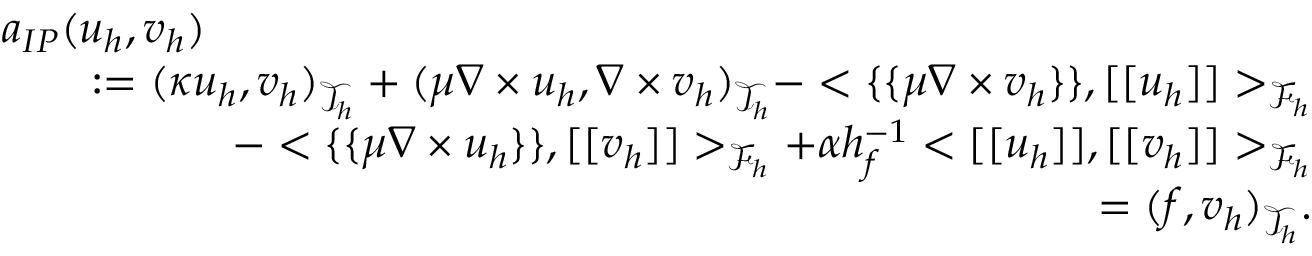Convert formula to latex. <formula><loc_0><loc_0><loc_500><loc_500>\begin{array} { r l r } { { a _ { I P } ( u _ { h } , v _ { h } ) } } \\ & { \colon = ( \kappa u _ { h } , v _ { h } ) _ { \mathcal { T } _ { h } } + ( \mu \nabla \times u _ { h } , \nabla \times v _ { h } ) _ { \mathcal { T } _ { h } } - < \{ \{ \mu \nabla \times v _ { h } \} \} , [ [ u _ { h } ] ] > _ { \mathcal { F } _ { h } } } \\ & { \quad - < \{ \{ \mu \nabla \times u _ { h } \} \} , [ [ v _ { h } ] ] > _ { \mathcal { F } _ { h } } + \alpha h _ { f } ^ { - 1 } < [ [ u _ { h } ] ] , [ [ v _ { h } ] ] > _ { \mathcal { F } _ { h } } } \\ & { = ( f , v _ { h } ) _ { \mathcal { T } _ { h } } . } \end{array}</formula> 